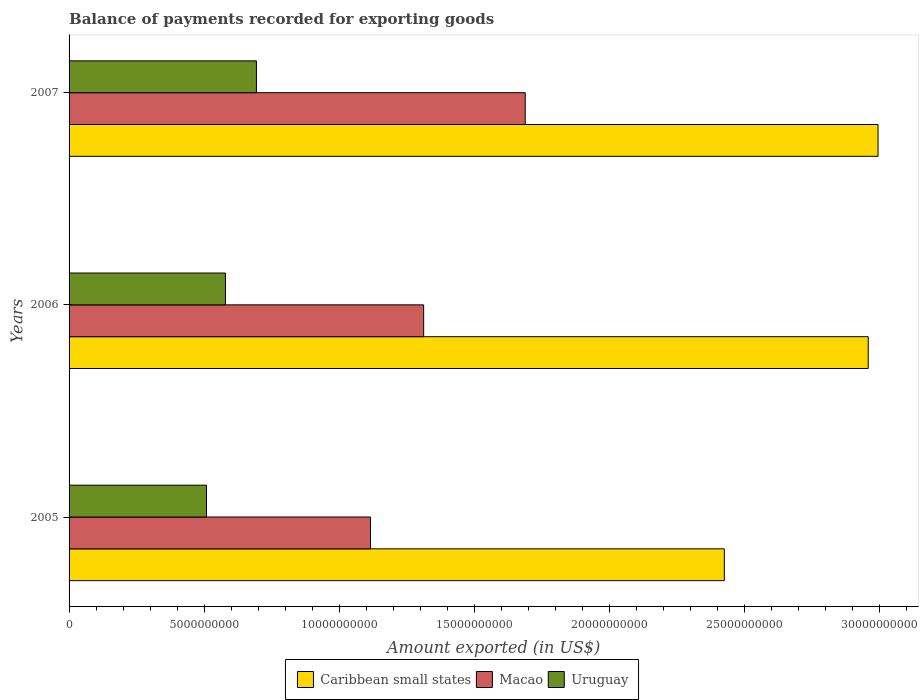How many groups of bars are there?
Your response must be concise. 3. Are the number of bars per tick equal to the number of legend labels?
Offer a terse response. Yes. Are the number of bars on each tick of the Y-axis equal?
Your answer should be compact. Yes. How many bars are there on the 3rd tick from the top?
Give a very brief answer. 3. How many bars are there on the 1st tick from the bottom?
Provide a short and direct response. 3. What is the label of the 1st group of bars from the top?
Offer a very short reply. 2007. What is the amount exported in Macao in 2007?
Provide a succinct answer. 1.69e+1. Across all years, what is the maximum amount exported in Macao?
Offer a very short reply. 1.69e+1. Across all years, what is the minimum amount exported in Uruguay?
Provide a succinct answer. 5.09e+09. In which year was the amount exported in Uruguay maximum?
Provide a short and direct response. 2007. In which year was the amount exported in Uruguay minimum?
Your answer should be very brief. 2005. What is the total amount exported in Uruguay in the graph?
Provide a short and direct response. 1.78e+1. What is the difference between the amount exported in Uruguay in 2006 and that in 2007?
Your answer should be very brief. -1.15e+09. What is the difference between the amount exported in Caribbean small states in 2006 and the amount exported in Uruguay in 2007?
Make the answer very short. 2.26e+1. What is the average amount exported in Macao per year?
Give a very brief answer. 1.37e+1. In the year 2007, what is the difference between the amount exported in Caribbean small states and amount exported in Macao?
Your answer should be compact. 1.31e+1. In how many years, is the amount exported in Caribbean small states greater than 4000000000 US$?
Offer a very short reply. 3. What is the ratio of the amount exported in Macao in 2005 to that in 2006?
Your answer should be very brief. 0.85. Is the difference between the amount exported in Caribbean small states in 2006 and 2007 greater than the difference between the amount exported in Macao in 2006 and 2007?
Give a very brief answer. Yes. What is the difference between the highest and the second highest amount exported in Caribbean small states?
Your answer should be compact. 3.64e+08. What is the difference between the highest and the lowest amount exported in Caribbean small states?
Your response must be concise. 5.69e+09. What does the 1st bar from the top in 2005 represents?
Your answer should be compact. Uruguay. What does the 1st bar from the bottom in 2005 represents?
Offer a terse response. Caribbean small states. Is it the case that in every year, the sum of the amount exported in Uruguay and amount exported in Macao is greater than the amount exported in Caribbean small states?
Your answer should be very brief. No. How many bars are there?
Offer a very short reply. 9. How many years are there in the graph?
Your response must be concise. 3. Where does the legend appear in the graph?
Make the answer very short. Bottom center. What is the title of the graph?
Your response must be concise. Balance of payments recorded for exporting goods. What is the label or title of the X-axis?
Make the answer very short. Amount exported (in US$). What is the Amount exported (in US$) of Caribbean small states in 2005?
Offer a terse response. 2.42e+1. What is the Amount exported (in US$) in Macao in 2005?
Ensure brevity in your answer.  1.12e+1. What is the Amount exported (in US$) in Uruguay in 2005?
Your answer should be very brief. 5.09e+09. What is the Amount exported (in US$) in Caribbean small states in 2006?
Offer a very short reply. 2.96e+1. What is the Amount exported (in US$) in Macao in 2006?
Make the answer very short. 1.31e+1. What is the Amount exported (in US$) in Uruguay in 2006?
Your answer should be compact. 5.79e+09. What is the Amount exported (in US$) in Caribbean small states in 2007?
Your response must be concise. 2.99e+1. What is the Amount exported (in US$) of Macao in 2007?
Give a very brief answer. 1.69e+1. What is the Amount exported (in US$) in Uruguay in 2007?
Your answer should be compact. 6.93e+09. Across all years, what is the maximum Amount exported (in US$) of Caribbean small states?
Offer a terse response. 2.99e+1. Across all years, what is the maximum Amount exported (in US$) of Macao?
Keep it short and to the point. 1.69e+1. Across all years, what is the maximum Amount exported (in US$) of Uruguay?
Your answer should be very brief. 6.93e+09. Across all years, what is the minimum Amount exported (in US$) of Caribbean small states?
Give a very brief answer. 2.42e+1. Across all years, what is the minimum Amount exported (in US$) of Macao?
Your answer should be very brief. 1.12e+1. Across all years, what is the minimum Amount exported (in US$) of Uruguay?
Your answer should be compact. 5.09e+09. What is the total Amount exported (in US$) of Caribbean small states in the graph?
Your answer should be very brief. 8.38e+1. What is the total Amount exported (in US$) in Macao in the graph?
Your response must be concise. 4.12e+1. What is the total Amount exported (in US$) in Uruguay in the graph?
Ensure brevity in your answer.  1.78e+1. What is the difference between the Amount exported (in US$) in Caribbean small states in 2005 and that in 2006?
Give a very brief answer. -5.32e+09. What is the difference between the Amount exported (in US$) in Macao in 2005 and that in 2006?
Your answer should be compact. -1.97e+09. What is the difference between the Amount exported (in US$) of Uruguay in 2005 and that in 2006?
Your answer should be very brief. -7.02e+08. What is the difference between the Amount exported (in US$) in Caribbean small states in 2005 and that in 2007?
Give a very brief answer. -5.69e+09. What is the difference between the Amount exported (in US$) of Macao in 2005 and that in 2007?
Offer a very short reply. -5.73e+09. What is the difference between the Amount exported (in US$) in Uruguay in 2005 and that in 2007?
Offer a very short reply. -1.85e+09. What is the difference between the Amount exported (in US$) of Caribbean small states in 2006 and that in 2007?
Offer a very short reply. -3.64e+08. What is the difference between the Amount exported (in US$) in Macao in 2006 and that in 2007?
Make the answer very short. -3.76e+09. What is the difference between the Amount exported (in US$) in Uruguay in 2006 and that in 2007?
Offer a terse response. -1.15e+09. What is the difference between the Amount exported (in US$) in Caribbean small states in 2005 and the Amount exported (in US$) in Macao in 2006?
Provide a succinct answer. 1.11e+1. What is the difference between the Amount exported (in US$) of Caribbean small states in 2005 and the Amount exported (in US$) of Uruguay in 2006?
Your answer should be compact. 1.85e+1. What is the difference between the Amount exported (in US$) in Macao in 2005 and the Amount exported (in US$) in Uruguay in 2006?
Your answer should be very brief. 5.37e+09. What is the difference between the Amount exported (in US$) of Caribbean small states in 2005 and the Amount exported (in US$) of Macao in 2007?
Keep it short and to the point. 7.37e+09. What is the difference between the Amount exported (in US$) in Caribbean small states in 2005 and the Amount exported (in US$) in Uruguay in 2007?
Keep it short and to the point. 1.73e+1. What is the difference between the Amount exported (in US$) in Macao in 2005 and the Amount exported (in US$) in Uruguay in 2007?
Provide a short and direct response. 4.22e+09. What is the difference between the Amount exported (in US$) in Caribbean small states in 2006 and the Amount exported (in US$) in Macao in 2007?
Your answer should be very brief. 1.27e+1. What is the difference between the Amount exported (in US$) in Caribbean small states in 2006 and the Amount exported (in US$) in Uruguay in 2007?
Provide a succinct answer. 2.26e+1. What is the difference between the Amount exported (in US$) of Macao in 2006 and the Amount exported (in US$) of Uruguay in 2007?
Your answer should be compact. 6.19e+09. What is the average Amount exported (in US$) in Caribbean small states per year?
Keep it short and to the point. 2.79e+1. What is the average Amount exported (in US$) of Macao per year?
Offer a terse response. 1.37e+1. What is the average Amount exported (in US$) in Uruguay per year?
Your answer should be compact. 5.94e+09. In the year 2005, what is the difference between the Amount exported (in US$) of Caribbean small states and Amount exported (in US$) of Macao?
Make the answer very short. 1.31e+1. In the year 2005, what is the difference between the Amount exported (in US$) in Caribbean small states and Amount exported (in US$) in Uruguay?
Make the answer very short. 1.92e+1. In the year 2005, what is the difference between the Amount exported (in US$) of Macao and Amount exported (in US$) of Uruguay?
Your answer should be very brief. 6.07e+09. In the year 2006, what is the difference between the Amount exported (in US$) of Caribbean small states and Amount exported (in US$) of Macao?
Your answer should be very brief. 1.65e+1. In the year 2006, what is the difference between the Amount exported (in US$) of Caribbean small states and Amount exported (in US$) of Uruguay?
Provide a succinct answer. 2.38e+1. In the year 2006, what is the difference between the Amount exported (in US$) of Macao and Amount exported (in US$) of Uruguay?
Provide a succinct answer. 7.33e+09. In the year 2007, what is the difference between the Amount exported (in US$) of Caribbean small states and Amount exported (in US$) of Macao?
Offer a terse response. 1.31e+1. In the year 2007, what is the difference between the Amount exported (in US$) of Caribbean small states and Amount exported (in US$) of Uruguay?
Your answer should be very brief. 2.30e+1. In the year 2007, what is the difference between the Amount exported (in US$) of Macao and Amount exported (in US$) of Uruguay?
Give a very brief answer. 9.95e+09. What is the ratio of the Amount exported (in US$) of Caribbean small states in 2005 to that in 2006?
Provide a succinct answer. 0.82. What is the ratio of the Amount exported (in US$) in Macao in 2005 to that in 2006?
Offer a very short reply. 0.85. What is the ratio of the Amount exported (in US$) in Uruguay in 2005 to that in 2006?
Make the answer very short. 0.88. What is the ratio of the Amount exported (in US$) of Caribbean small states in 2005 to that in 2007?
Ensure brevity in your answer.  0.81. What is the ratio of the Amount exported (in US$) of Macao in 2005 to that in 2007?
Your response must be concise. 0.66. What is the ratio of the Amount exported (in US$) of Uruguay in 2005 to that in 2007?
Keep it short and to the point. 0.73. What is the ratio of the Amount exported (in US$) in Caribbean small states in 2006 to that in 2007?
Make the answer very short. 0.99. What is the ratio of the Amount exported (in US$) of Macao in 2006 to that in 2007?
Keep it short and to the point. 0.78. What is the ratio of the Amount exported (in US$) in Uruguay in 2006 to that in 2007?
Provide a succinct answer. 0.83. What is the difference between the highest and the second highest Amount exported (in US$) of Caribbean small states?
Provide a short and direct response. 3.64e+08. What is the difference between the highest and the second highest Amount exported (in US$) of Macao?
Make the answer very short. 3.76e+09. What is the difference between the highest and the second highest Amount exported (in US$) in Uruguay?
Provide a succinct answer. 1.15e+09. What is the difference between the highest and the lowest Amount exported (in US$) of Caribbean small states?
Keep it short and to the point. 5.69e+09. What is the difference between the highest and the lowest Amount exported (in US$) of Macao?
Offer a terse response. 5.73e+09. What is the difference between the highest and the lowest Amount exported (in US$) of Uruguay?
Give a very brief answer. 1.85e+09. 